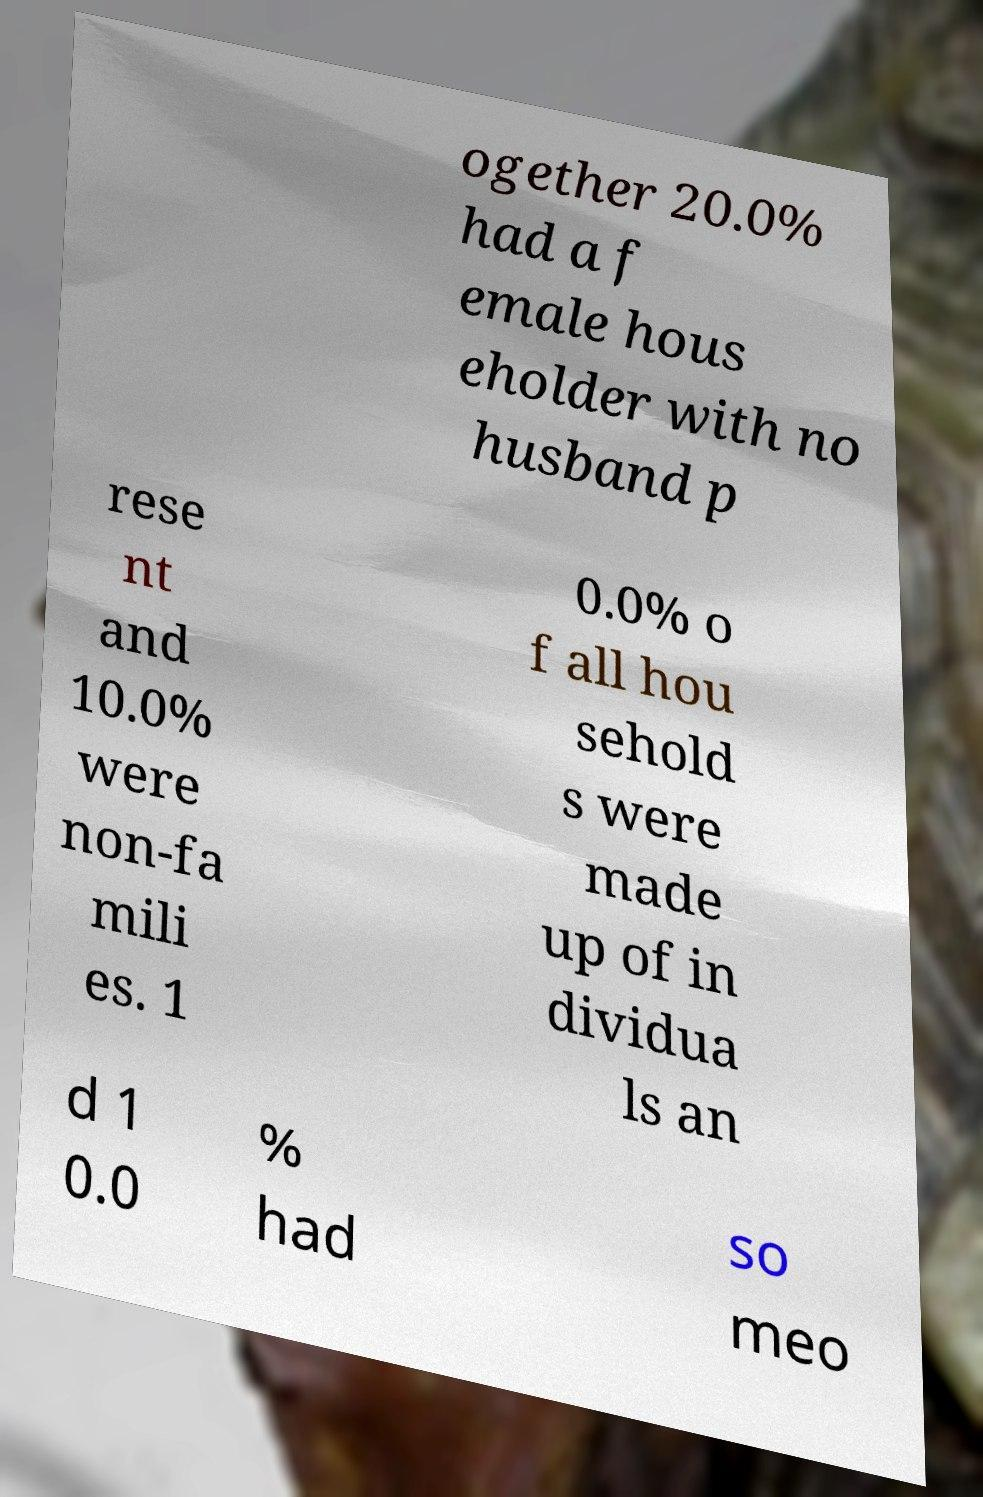Could you extract and type out the text from this image? ogether 20.0% had a f emale hous eholder with no husband p rese nt and 10.0% were non-fa mili es. 1 0.0% o f all hou sehold s were made up of in dividua ls an d 1 0.0 % had so meo 